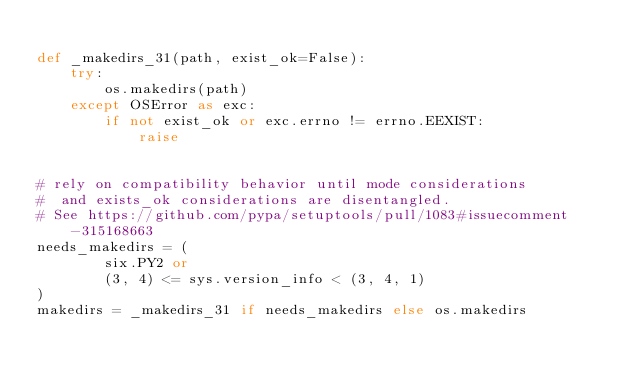<code> <loc_0><loc_0><loc_500><loc_500><_Python_>
def _makedirs_31(path, exist_ok=False):
    try:
        os.makedirs(path)
    except OSError as exc:
        if not exist_ok or exc.errno != errno.EEXIST:
            raise


# rely on compatibility behavior until mode considerations
#  and exists_ok considerations are disentangled.
# See https://github.com/pypa/setuptools/pull/1083#issuecomment-315168663
needs_makedirs = (
        six.PY2 or
        (3, 4) <= sys.version_info < (3, 4, 1)
)
makedirs = _makedirs_31 if needs_makedirs else os.makedirs
</code> 